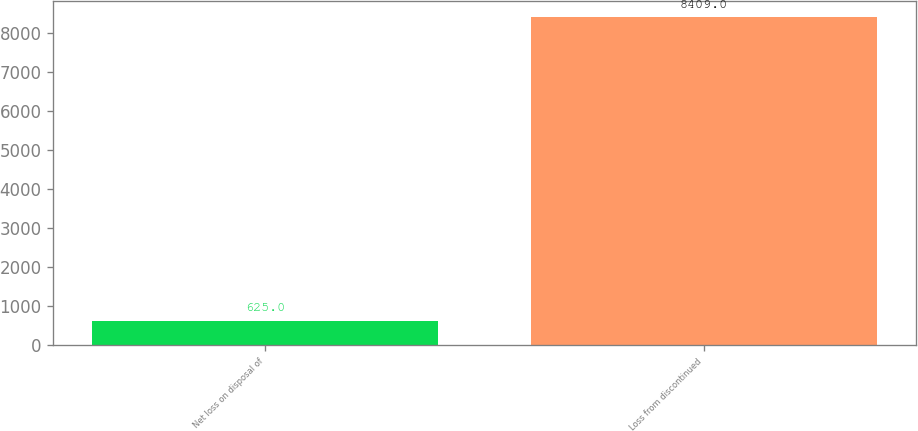<chart> <loc_0><loc_0><loc_500><loc_500><bar_chart><fcel>Net loss on disposal of<fcel>Loss from discontinued<nl><fcel>625<fcel>8409<nl></chart> 